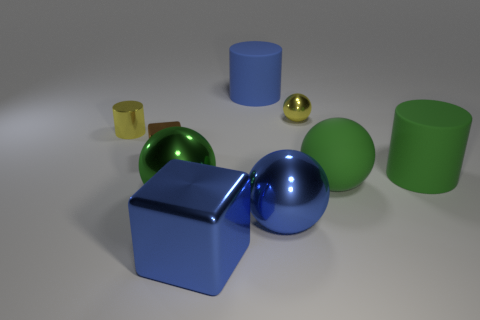Subtract 1 balls. How many balls are left? 3 Add 1 tiny shiny objects. How many objects exist? 10 Subtract all cylinders. How many objects are left? 6 Subtract 0 purple balls. How many objects are left? 9 Subtract all big blocks. Subtract all big blue shiny things. How many objects are left? 6 Add 8 matte cylinders. How many matte cylinders are left? 10 Add 9 big cubes. How many big cubes exist? 10 